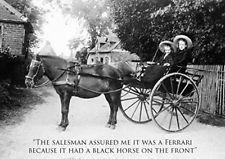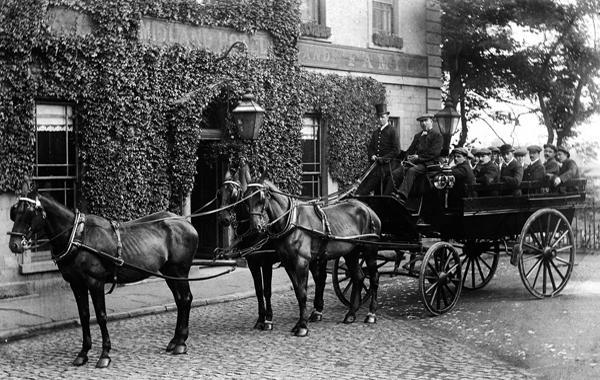The first image is the image on the left, the second image is the image on the right. Analyze the images presented: Is the assertion "The left image shows a two-wheeled wagon with no passengers." valid? Answer yes or no. No. The first image is the image on the left, the second image is the image on the right. Evaluate the accuracy of this statement regarding the images: "Two horses are pulling a single cart in the image on the right.". Is it true? Answer yes or no. Yes. 